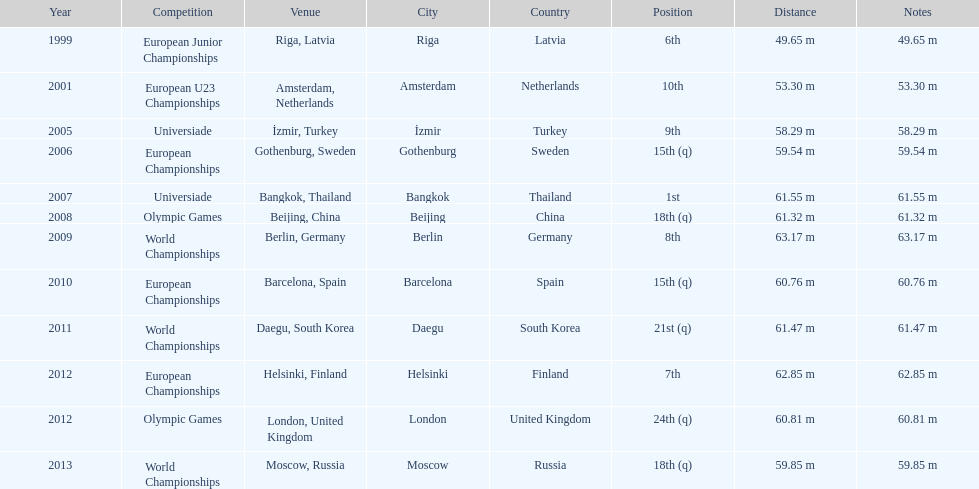How what listed year was a distance of only 53.30m reached? 2001. 